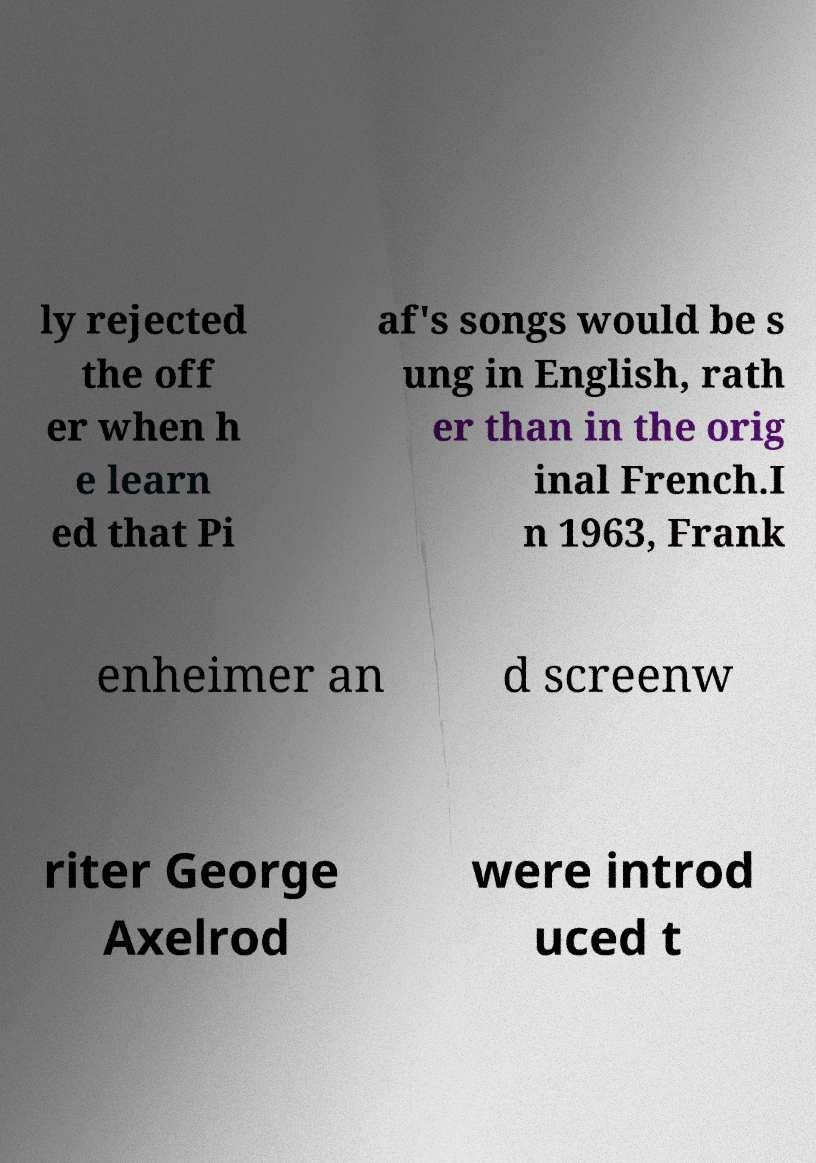What messages or text are displayed in this image? I need them in a readable, typed format. ly rejected the off er when h e learn ed that Pi af's songs would be s ung in English, rath er than in the orig inal French.I n 1963, Frank enheimer an d screenw riter George Axelrod were introd uced t 